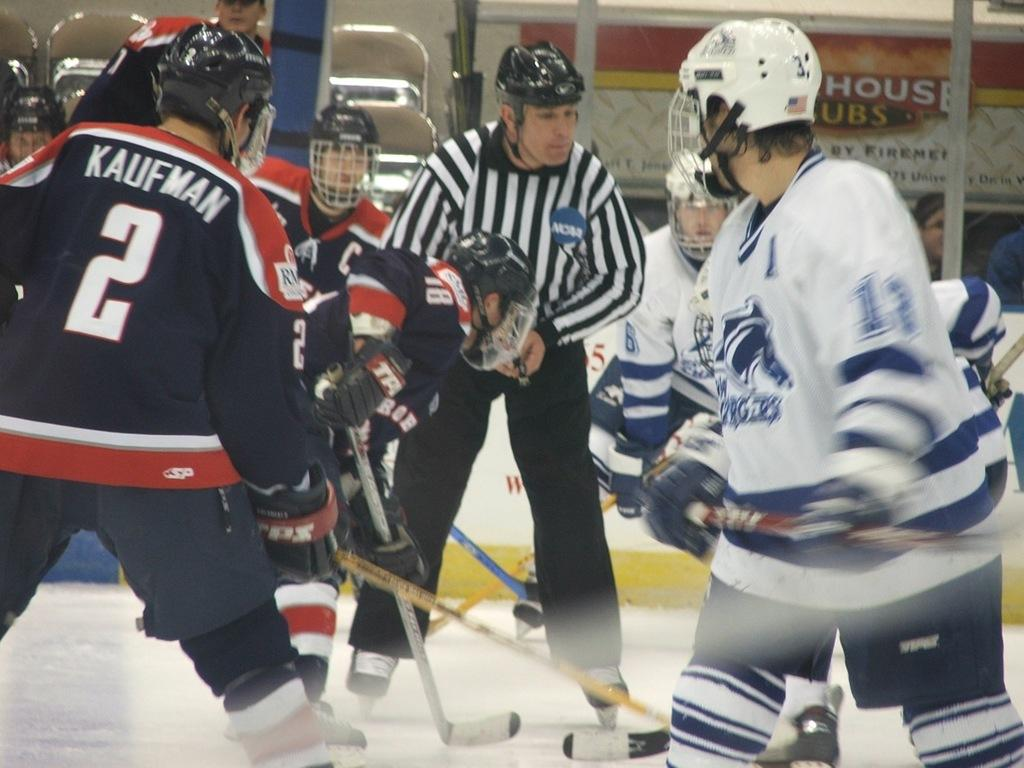What is happening in the center of the image? There are people in the center of the image, and they are playing. What can be seen at the top side of the image? There is a poster at the top side of the image. What is present at the bottom side of the image? There is snow at the bottom side of the image. What type of teaching is happening on the island in the image? There is no island present in the image, and no teaching is happening. Additionally, there are no ants in the image. 